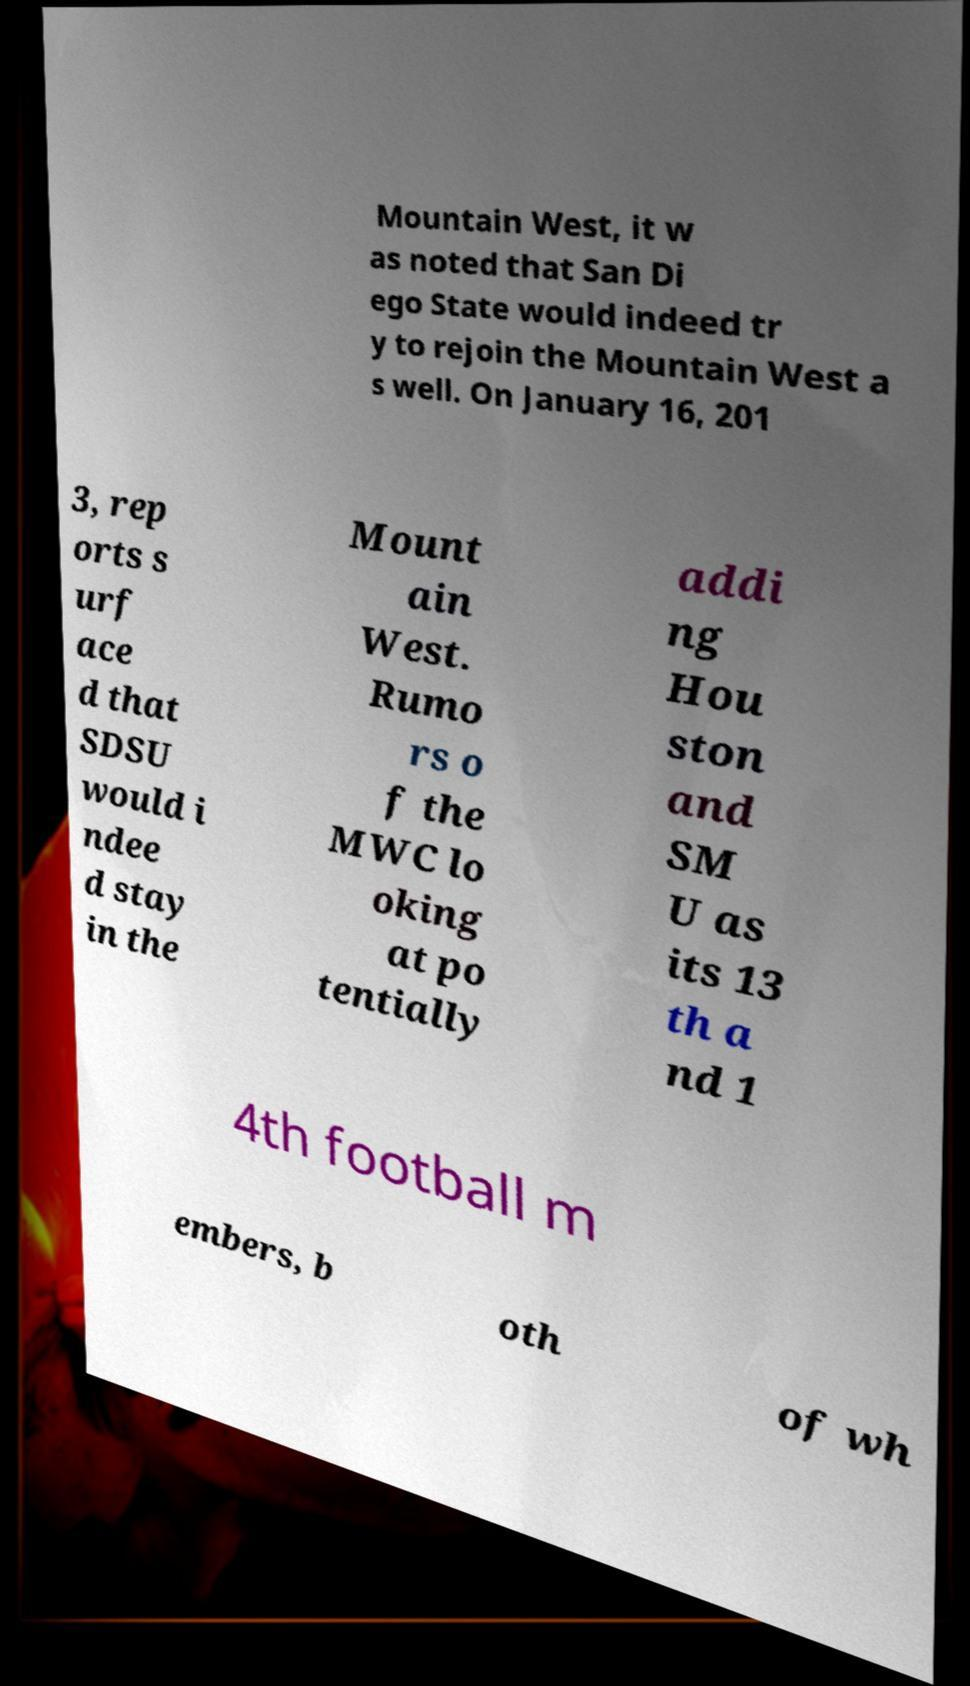Please identify and transcribe the text found in this image. Mountain West, it w as noted that San Di ego State would indeed tr y to rejoin the Mountain West a s well. On January 16, 201 3, rep orts s urf ace d that SDSU would i ndee d stay in the Mount ain West. Rumo rs o f the MWC lo oking at po tentially addi ng Hou ston and SM U as its 13 th a nd 1 4th football m embers, b oth of wh 